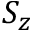<formula> <loc_0><loc_0><loc_500><loc_500>S _ { z }</formula> 